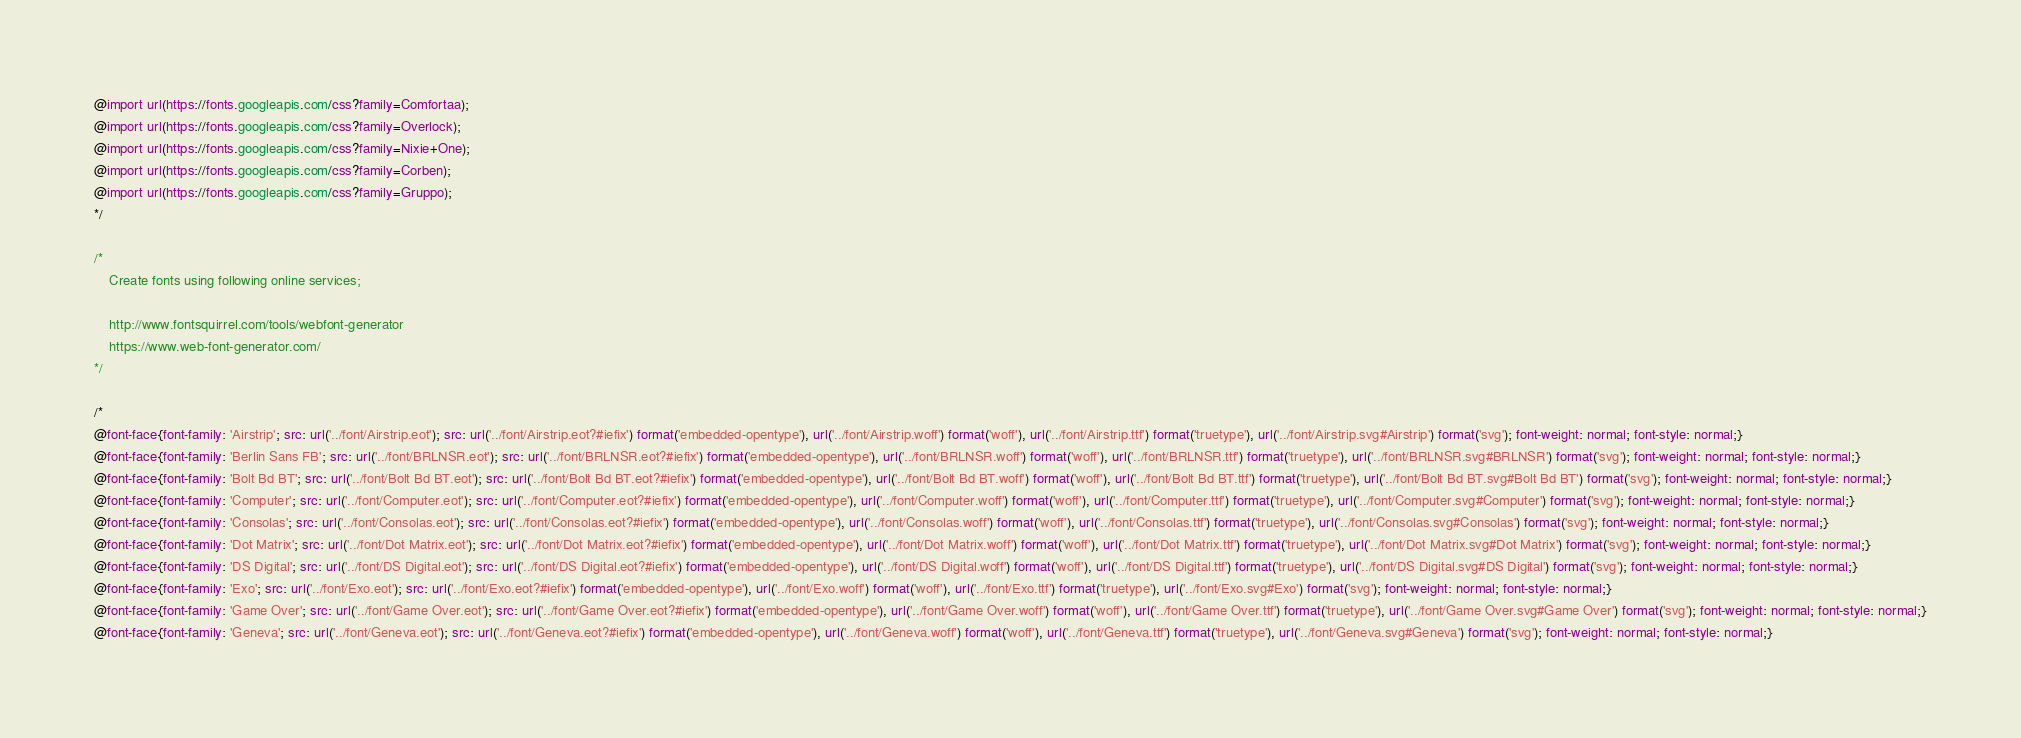<code> <loc_0><loc_0><loc_500><loc_500><_CSS_>@import url(https://fonts.googleapis.com/css?family=Comfortaa);
@import url(https://fonts.googleapis.com/css?family=Overlock);
@import url(https://fonts.googleapis.com/css?family=Nixie+One);
@import url(https://fonts.googleapis.com/css?family=Corben);
@import url(https://fonts.googleapis.com/css?family=Gruppo);
*/

/*
	Create fonts using following online services;

	http://www.fontsquirrel.com/tools/webfont-generator
	https://www.web-font-generator.com/
*/

/*
@font-face{font-family: 'Airstrip'; src: url('../font/Airstrip.eot'); src: url('../font/Airstrip.eot?#iefix') format('embedded-opentype'), url('../font/Airstrip.woff') format('woff'), url('../font/Airstrip.ttf') format('truetype'), url('../font/Airstrip.svg#Airstrip') format('svg'); font-weight: normal; font-style: normal;}
@font-face{font-family: 'Berlin Sans FB'; src: url('../font/BRLNSR.eot'); src: url('../font/BRLNSR.eot?#iefix') format('embedded-opentype'), url('../font/BRLNSR.woff') format('woff'), url('../font/BRLNSR.ttf') format('truetype'), url('../font/BRLNSR.svg#BRLNSR') format('svg'); font-weight: normal; font-style: normal;}
@font-face{font-family: 'Bolt Bd BT'; src: url('../font/Bolt Bd BT.eot'); src: url('../font/Bolt Bd BT.eot?#iefix') format('embedded-opentype'), url('../font/Bolt Bd BT.woff') format('woff'), url('../font/Bolt Bd BT.ttf') format('truetype'), url('../font/Bolt Bd BT.svg#Bolt Bd BT') format('svg'); font-weight: normal; font-style: normal;}
@font-face{font-family: 'Computer'; src: url('../font/Computer.eot'); src: url('../font/Computer.eot?#iefix') format('embedded-opentype'), url('../font/Computer.woff') format('woff'), url('../font/Computer.ttf') format('truetype'), url('../font/Computer.svg#Computer') format('svg'); font-weight: normal; font-style: normal;}
@font-face{font-family: 'Consolas'; src: url('../font/Consolas.eot'); src: url('../font/Consolas.eot?#iefix') format('embedded-opentype'), url('../font/Consolas.woff') format('woff'), url('../font/Consolas.ttf') format('truetype'), url('../font/Consolas.svg#Consolas') format('svg'); font-weight: normal; font-style: normal;}
@font-face{font-family: 'Dot Matrix'; src: url('../font/Dot Matrix.eot'); src: url('../font/Dot Matrix.eot?#iefix') format('embedded-opentype'), url('../font/Dot Matrix.woff') format('woff'), url('../font/Dot Matrix.ttf') format('truetype'), url('../font/Dot Matrix.svg#Dot Matrix') format('svg'); font-weight: normal; font-style: normal;}
@font-face{font-family: 'DS Digital'; src: url('../font/DS Digital.eot'); src: url('../font/DS Digital.eot?#iefix') format('embedded-opentype'), url('../font/DS Digital.woff') format('woff'), url('../font/DS Digital.ttf') format('truetype'), url('../font/DS Digital.svg#DS Digital') format('svg'); font-weight: normal; font-style: normal;}
@font-face{font-family: 'Exo'; src: url('../font/Exo.eot'); src: url('../font/Exo.eot?#iefix') format('embedded-opentype'), url('../font/Exo.woff') format('woff'), url('../font/Exo.ttf') format('truetype'), url('../font/Exo.svg#Exo') format('svg'); font-weight: normal; font-style: normal;}
@font-face{font-family: 'Game Over'; src: url('../font/Game Over.eot'); src: url('../font/Game Over.eot?#iefix') format('embedded-opentype'), url('../font/Game Over.woff') format('woff'), url('../font/Game Over.ttf') format('truetype'), url('../font/Game Over.svg#Game Over') format('svg'); font-weight: normal; font-style: normal;}
@font-face{font-family: 'Geneva'; src: url('../font/Geneva.eot'); src: url('../font/Geneva.eot?#iefix') format('embedded-opentype'), url('../font/Geneva.woff') format('woff'), url('../font/Geneva.ttf') format('truetype'), url('../font/Geneva.svg#Geneva') format('svg'); font-weight: normal; font-style: normal;}</code> 